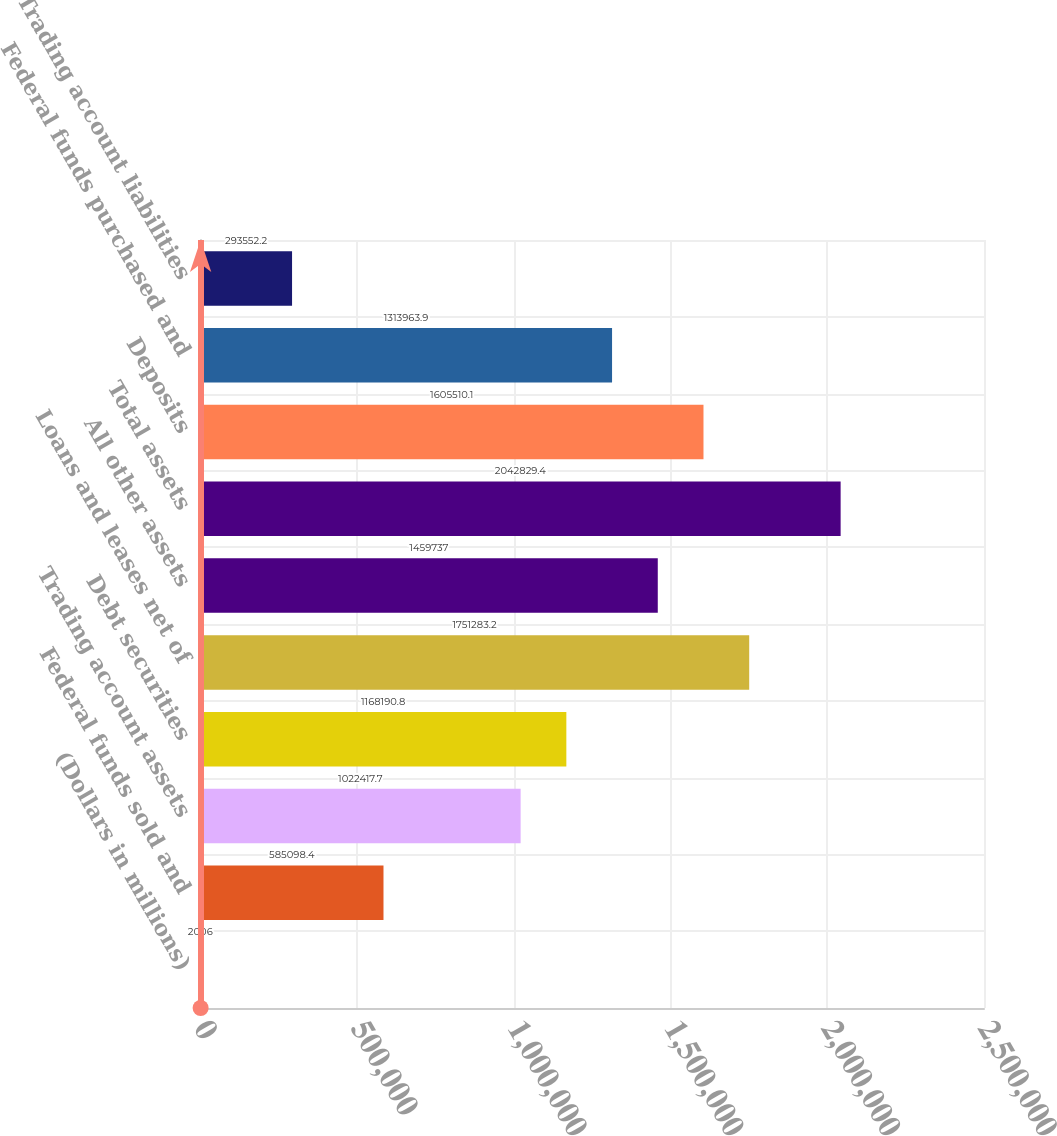<chart> <loc_0><loc_0><loc_500><loc_500><bar_chart><fcel>(Dollars in millions)<fcel>Federal funds sold and<fcel>Trading account assets<fcel>Debt securities<fcel>Loans and leases net of<fcel>All other assets<fcel>Total assets<fcel>Deposits<fcel>Federal funds purchased and<fcel>Trading account liabilities<nl><fcel>2006<fcel>585098<fcel>1.02242e+06<fcel>1.16819e+06<fcel>1.75128e+06<fcel>1.45974e+06<fcel>2.04283e+06<fcel>1.60551e+06<fcel>1.31396e+06<fcel>293552<nl></chart> 